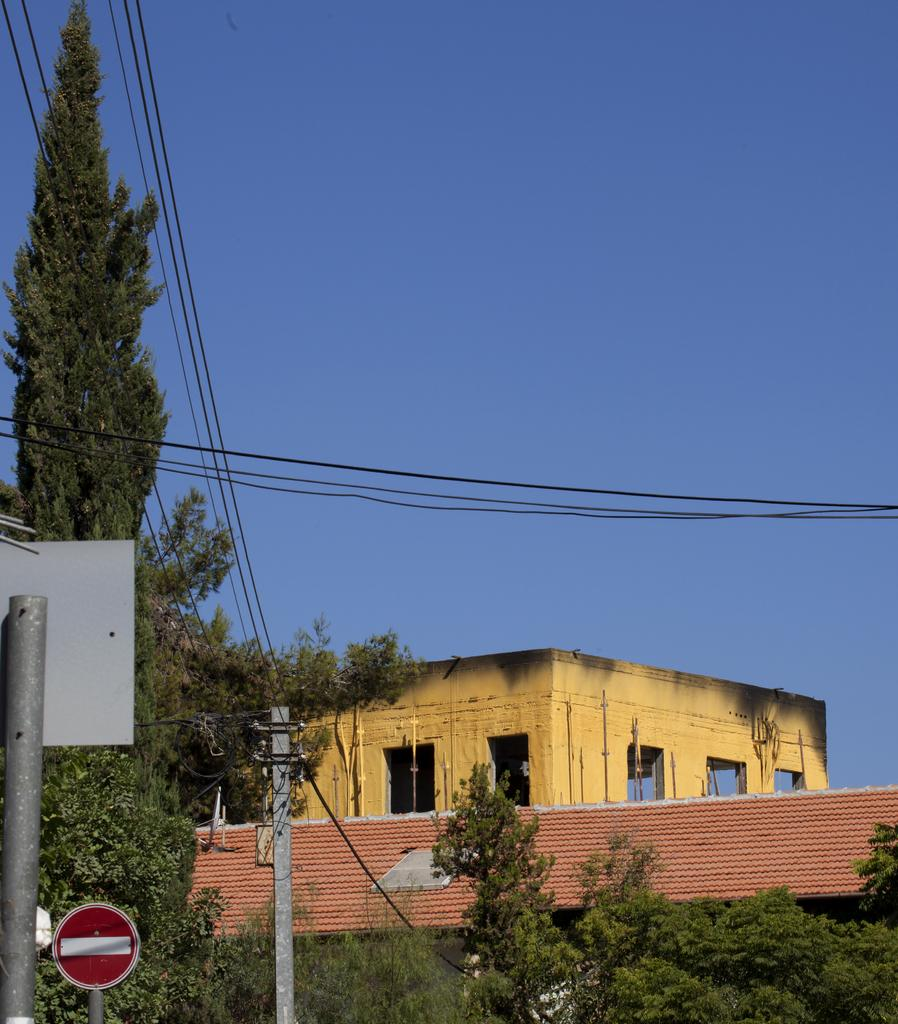What structures can be seen in the image? There are poles and electrical wires in the image. What natural elements are present in the image? There are many trees in the image. What type of human activity is taking place in the image? There is a construction site beside the trees. What type of hair can be seen on the goose in the image? There is no goose or hair present in the image. 